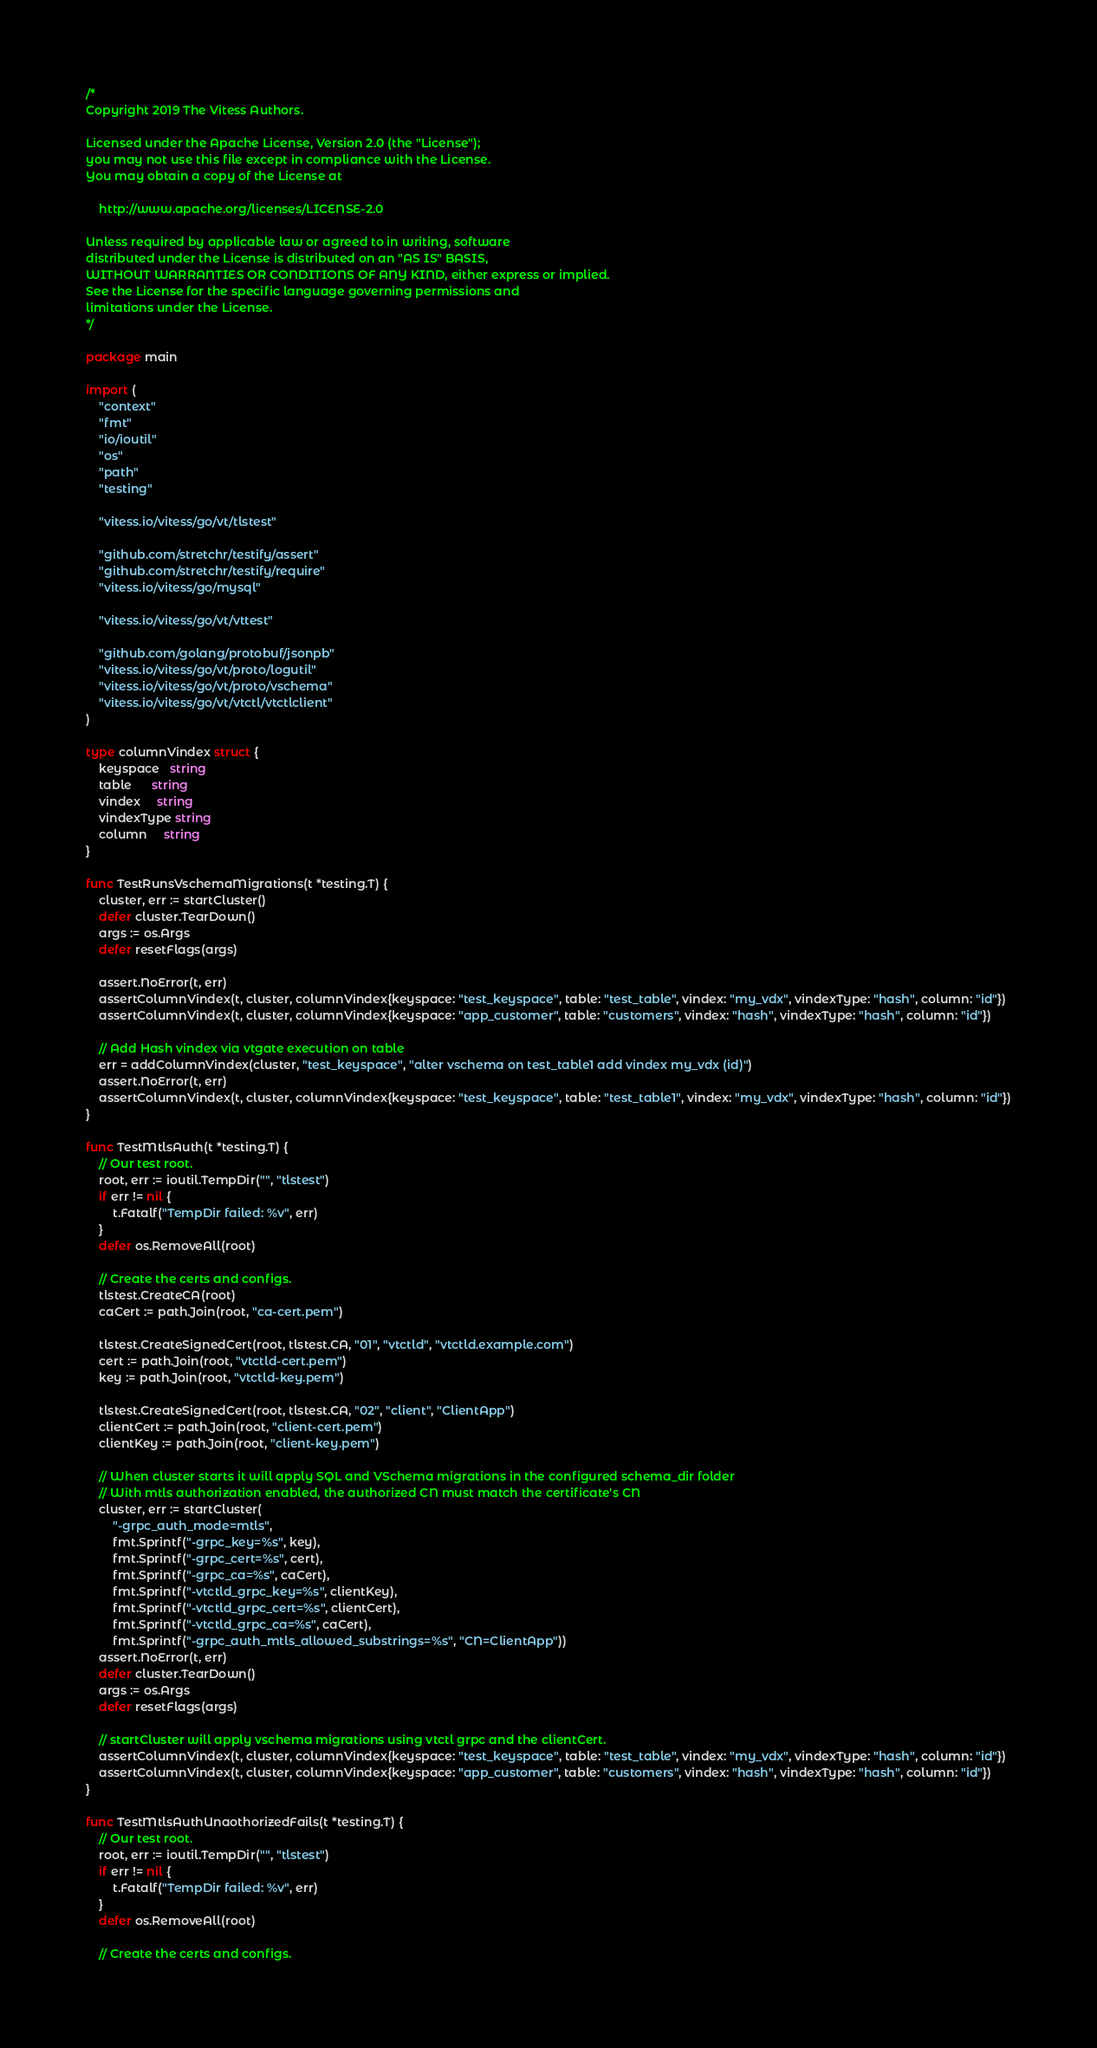<code> <loc_0><loc_0><loc_500><loc_500><_Go_>/*
Copyright 2019 The Vitess Authors.

Licensed under the Apache License, Version 2.0 (the "License");
you may not use this file except in compliance with the License.
You may obtain a copy of the License at

    http://www.apache.org/licenses/LICENSE-2.0

Unless required by applicable law or agreed to in writing, software
distributed under the License is distributed on an "AS IS" BASIS,
WITHOUT WARRANTIES OR CONDITIONS OF ANY KIND, either express or implied.
See the License for the specific language governing permissions and
limitations under the License.
*/

package main

import (
	"context"
	"fmt"
	"io/ioutil"
	"os"
	"path"
	"testing"

	"vitess.io/vitess/go/vt/tlstest"

	"github.com/stretchr/testify/assert"
	"github.com/stretchr/testify/require"
	"vitess.io/vitess/go/mysql"

	"vitess.io/vitess/go/vt/vttest"

	"github.com/golang/protobuf/jsonpb"
	"vitess.io/vitess/go/vt/proto/logutil"
	"vitess.io/vitess/go/vt/proto/vschema"
	"vitess.io/vitess/go/vt/vtctl/vtctlclient"
)

type columnVindex struct {
	keyspace   string
	table      string
	vindex     string
	vindexType string
	column     string
}

func TestRunsVschemaMigrations(t *testing.T) {
	cluster, err := startCluster()
	defer cluster.TearDown()
	args := os.Args
	defer resetFlags(args)

	assert.NoError(t, err)
	assertColumnVindex(t, cluster, columnVindex{keyspace: "test_keyspace", table: "test_table", vindex: "my_vdx", vindexType: "hash", column: "id"})
	assertColumnVindex(t, cluster, columnVindex{keyspace: "app_customer", table: "customers", vindex: "hash", vindexType: "hash", column: "id"})

	// Add Hash vindex via vtgate execution on table
	err = addColumnVindex(cluster, "test_keyspace", "alter vschema on test_table1 add vindex my_vdx (id)")
	assert.NoError(t, err)
	assertColumnVindex(t, cluster, columnVindex{keyspace: "test_keyspace", table: "test_table1", vindex: "my_vdx", vindexType: "hash", column: "id"})
}

func TestMtlsAuth(t *testing.T) {
	// Our test root.
	root, err := ioutil.TempDir("", "tlstest")
	if err != nil {
		t.Fatalf("TempDir failed: %v", err)
	}
	defer os.RemoveAll(root)

	// Create the certs and configs.
	tlstest.CreateCA(root)
	caCert := path.Join(root, "ca-cert.pem")

	tlstest.CreateSignedCert(root, tlstest.CA, "01", "vtctld", "vtctld.example.com")
	cert := path.Join(root, "vtctld-cert.pem")
	key := path.Join(root, "vtctld-key.pem")

	tlstest.CreateSignedCert(root, tlstest.CA, "02", "client", "ClientApp")
	clientCert := path.Join(root, "client-cert.pem")
	clientKey := path.Join(root, "client-key.pem")

	// When cluster starts it will apply SQL and VSchema migrations in the configured schema_dir folder
	// With mtls authorization enabled, the authorized CN must match the certificate's CN
	cluster, err := startCluster(
		"-grpc_auth_mode=mtls",
		fmt.Sprintf("-grpc_key=%s", key),
		fmt.Sprintf("-grpc_cert=%s", cert),
		fmt.Sprintf("-grpc_ca=%s", caCert),
		fmt.Sprintf("-vtctld_grpc_key=%s", clientKey),
		fmt.Sprintf("-vtctld_grpc_cert=%s", clientCert),
		fmt.Sprintf("-vtctld_grpc_ca=%s", caCert),
		fmt.Sprintf("-grpc_auth_mtls_allowed_substrings=%s", "CN=ClientApp"))
	assert.NoError(t, err)
	defer cluster.TearDown()
	args := os.Args
	defer resetFlags(args)

	// startCluster will apply vschema migrations using vtctl grpc and the clientCert.
	assertColumnVindex(t, cluster, columnVindex{keyspace: "test_keyspace", table: "test_table", vindex: "my_vdx", vindexType: "hash", column: "id"})
	assertColumnVindex(t, cluster, columnVindex{keyspace: "app_customer", table: "customers", vindex: "hash", vindexType: "hash", column: "id"})
}

func TestMtlsAuthUnaothorizedFails(t *testing.T) {
	// Our test root.
	root, err := ioutil.TempDir("", "tlstest")
	if err != nil {
		t.Fatalf("TempDir failed: %v", err)
	}
	defer os.RemoveAll(root)

	// Create the certs and configs.</code> 